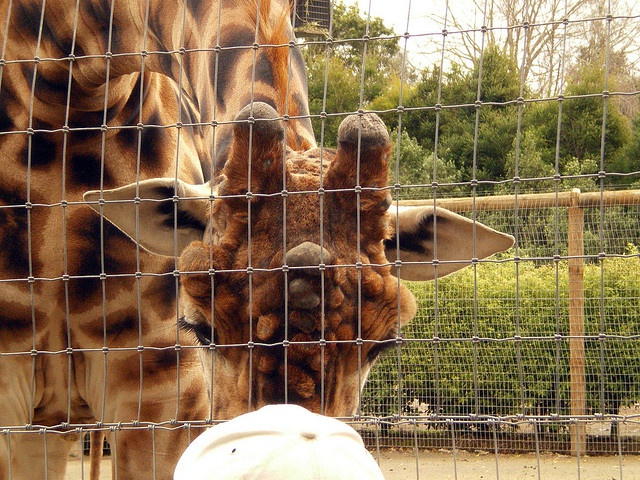Describe the objects in this image and their specific colors. I can see giraffe in maroon, black, brown, and gray tones and people in maroon, ivory, tan, and brown tones in this image. 